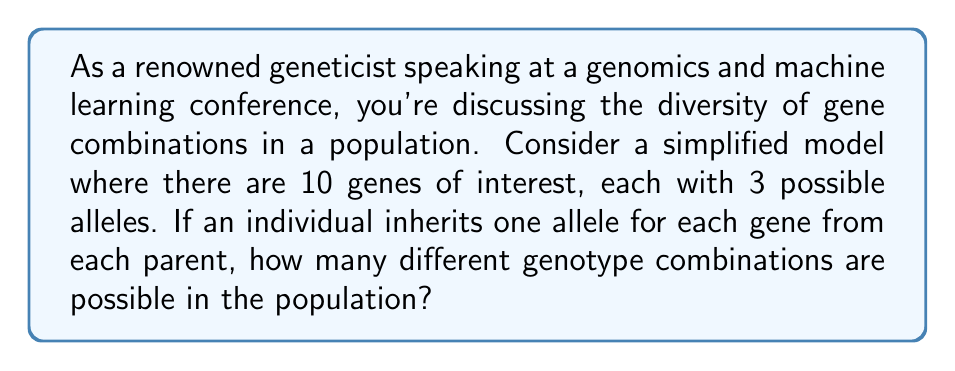Solve this math problem. To solve this problem, we need to use the multiplication principle of counting. Let's break it down step-by-step:

1. For each gene, an individual inherits one allele from each parent. This means there are 3 possibilities for each parent's contribution.

2. The number of possible combinations for a single gene is therefore:
   $3 \times 3 = 9$

3. We have 10 different genes, and for each gene, we have 9 possible combinations.

4. To find the total number of possible genotype combinations, we multiply the number of possibilities for each gene:

   $$ \text{Total combinations} = 9^{10} $$

5. Let's calculate this:
   $$ 9^{10} = 3,486,784,401 $$

This large number demonstrates the incredible genetic diversity possible even with a relatively small number of genes and alleles. In reality, the human genome contains approximately 20,000-25,000 genes, many with multiple alleles, leading to an astronomical number of possible combinations.

This concept is crucial in population genetics and has significant implications for personalized medicine and machine learning applications in genomics, where we need to consider the vast variability in genetic makeup across individuals and populations.
Answer: $3,486,784,401$ 